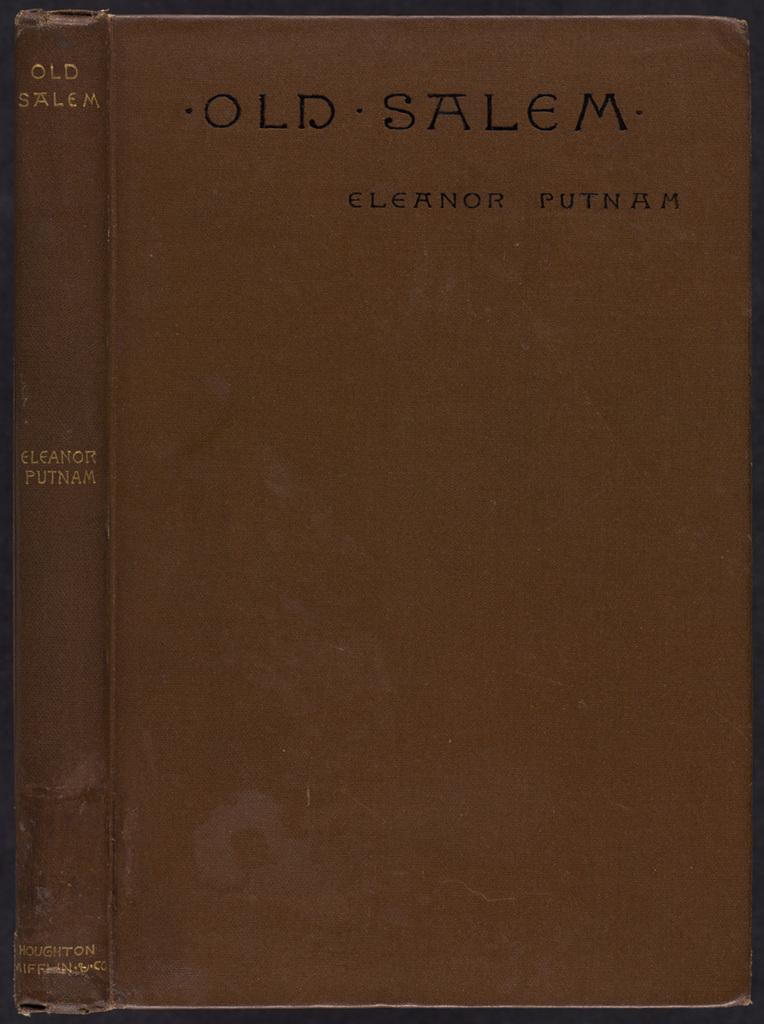<image>
Summarize the visual content of the image. A brown book of Old Salem by Eleanor Putnam. 